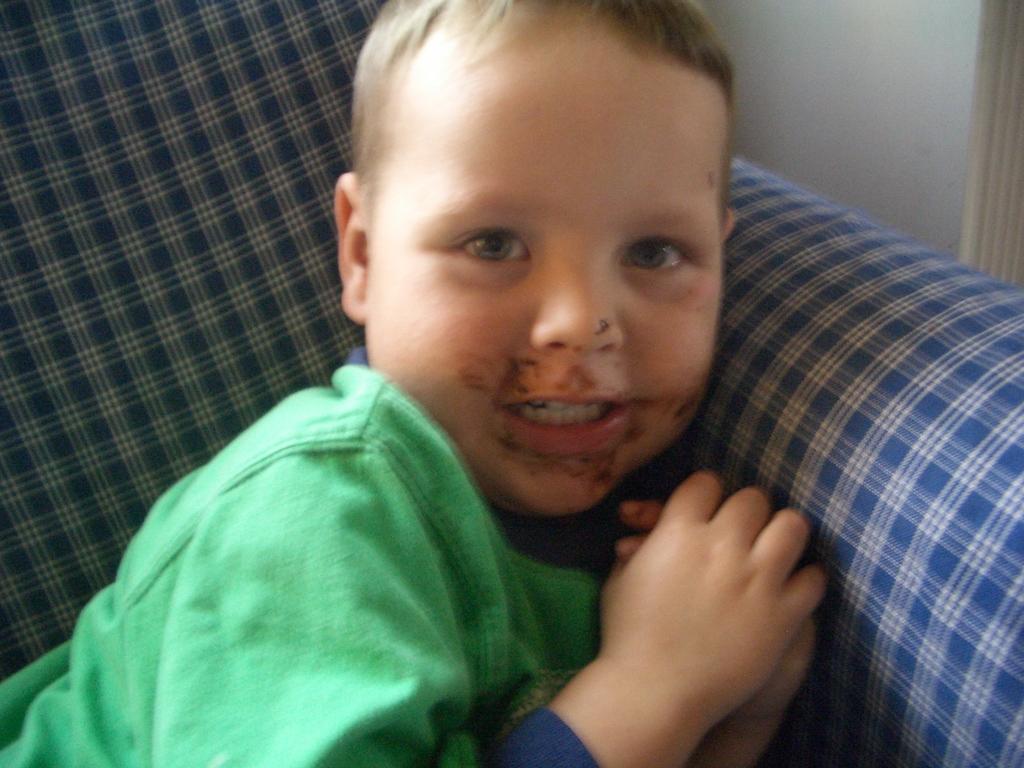Describe this image in one or two sentences. In the picture I can see a boy who is wearing green color clothes. In the background I can see blue color object. 